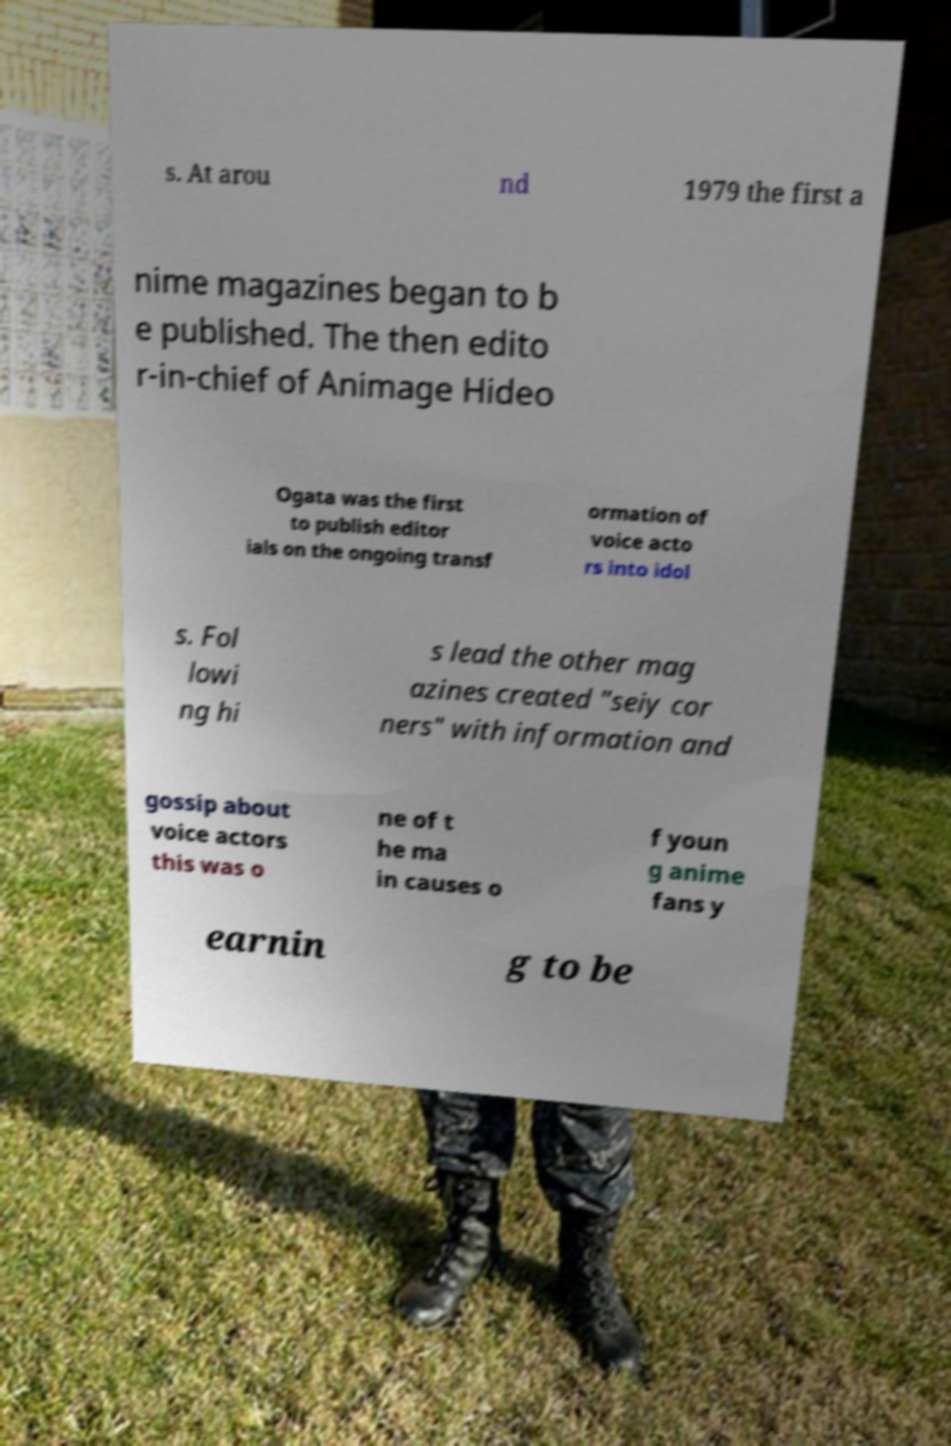Could you assist in decoding the text presented in this image and type it out clearly? s. At arou nd 1979 the first a nime magazines began to b e published. The then edito r-in-chief of Animage Hideo Ogata was the first to publish editor ials on the ongoing transf ormation of voice acto rs into idol s. Fol lowi ng hi s lead the other mag azines created "seiy cor ners" with information and gossip about voice actors this was o ne of t he ma in causes o f youn g anime fans y earnin g to be 